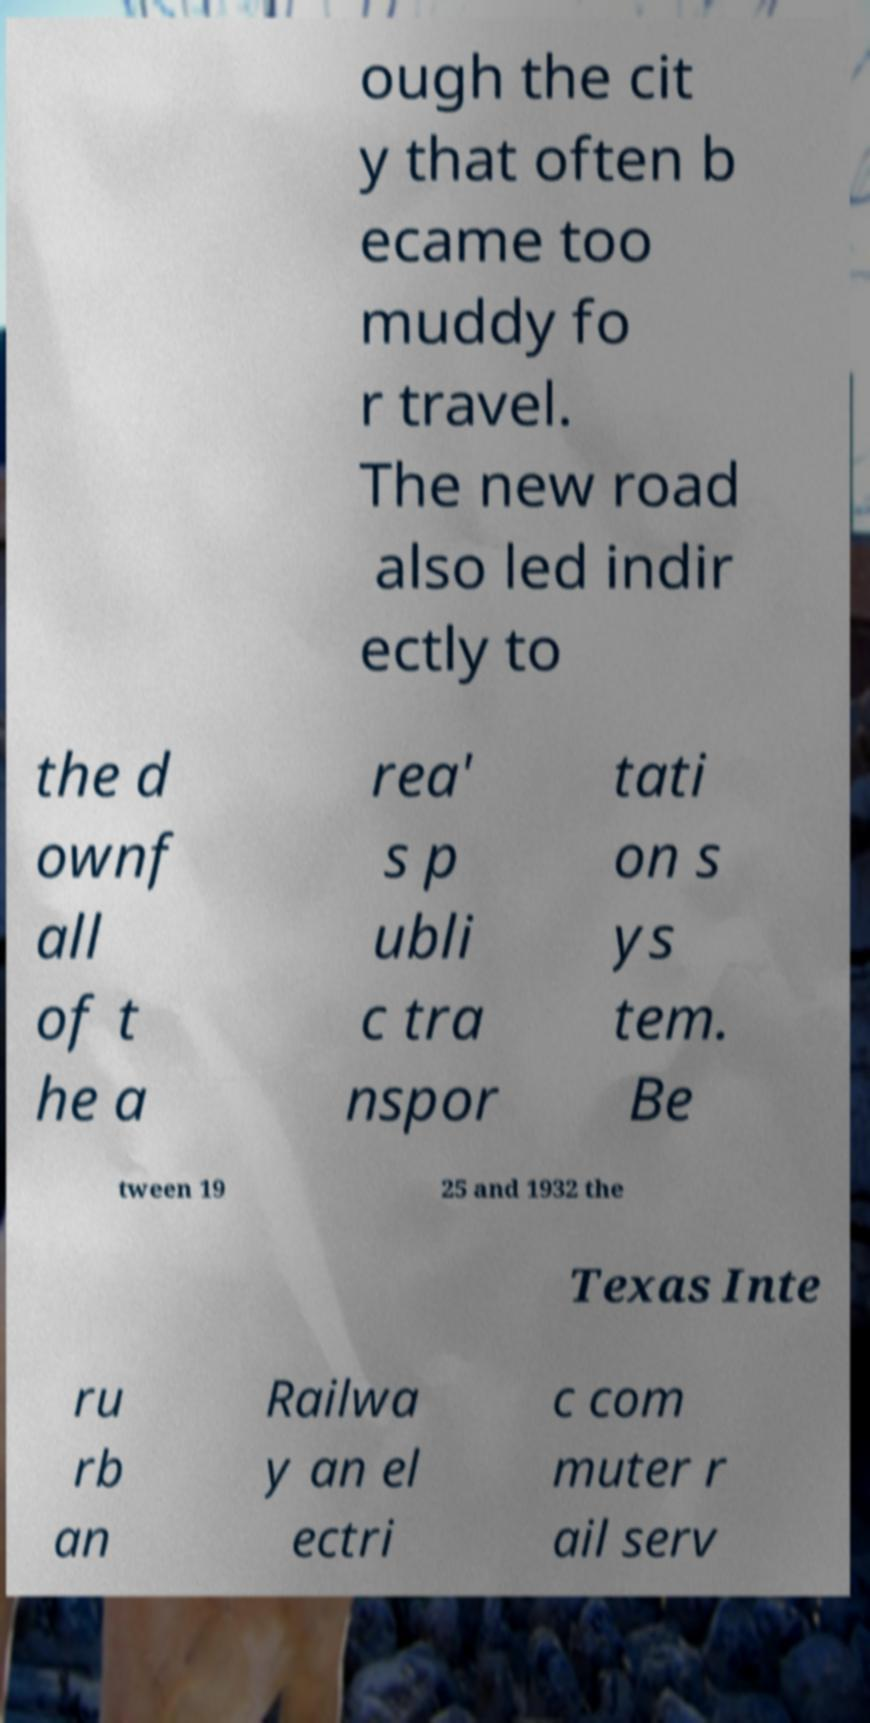What messages or text are displayed in this image? I need them in a readable, typed format. ough the cit y that often b ecame too muddy fo r travel. The new road also led indir ectly to the d ownf all of t he a rea' s p ubli c tra nspor tati on s ys tem. Be tween 19 25 and 1932 the Texas Inte ru rb an Railwa y an el ectri c com muter r ail serv 